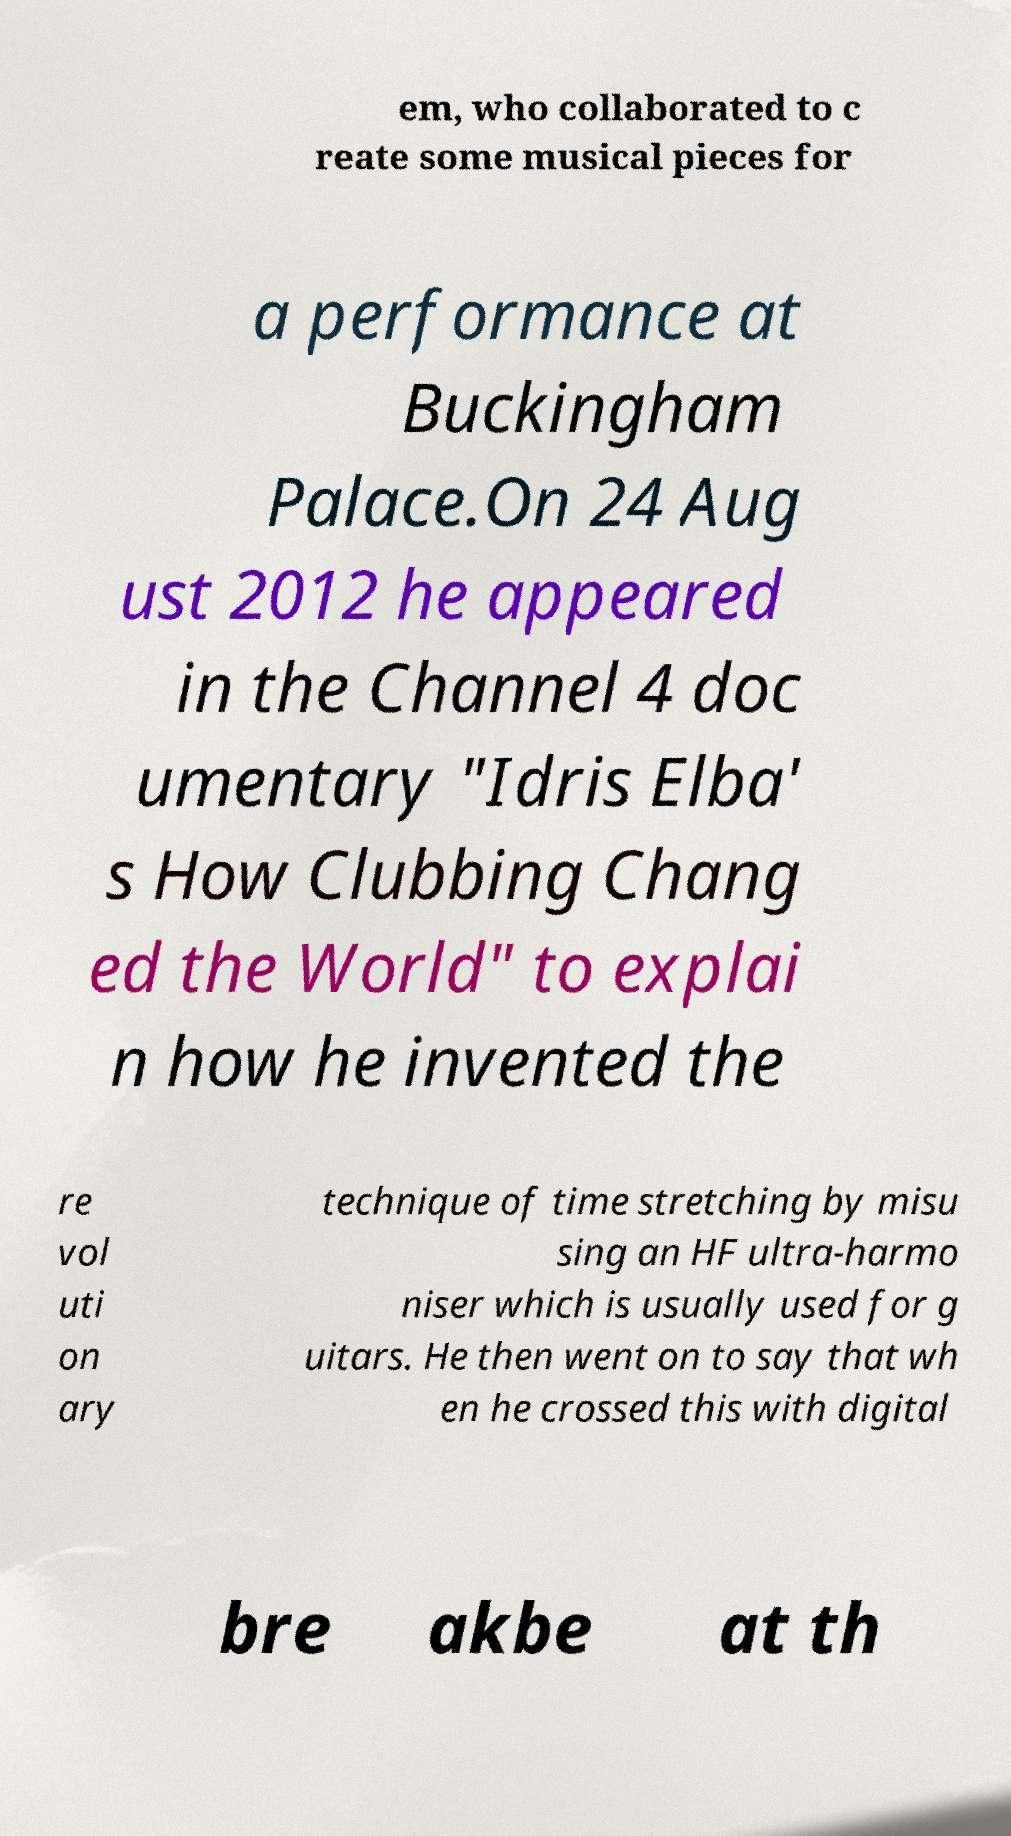Could you assist in decoding the text presented in this image and type it out clearly? em, who collaborated to c reate some musical pieces for a performance at Buckingham Palace.On 24 Aug ust 2012 he appeared in the Channel 4 doc umentary "Idris Elba' s How Clubbing Chang ed the World" to explai n how he invented the re vol uti on ary technique of time stretching by misu sing an HF ultra-harmo niser which is usually used for g uitars. He then went on to say that wh en he crossed this with digital bre akbe at th 